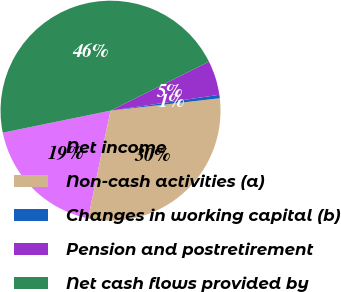<chart> <loc_0><loc_0><loc_500><loc_500><pie_chart><fcel>Net income<fcel>Non-cash activities (a)<fcel>Changes in working capital (b)<fcel>Pension and postretirement<fcel>Net cash flows provided by<nl><fcel>18.52%<fcel>30.07%<fcel>0.51%<fcel>5.04%<fcel>45.86%<nl></chart> 